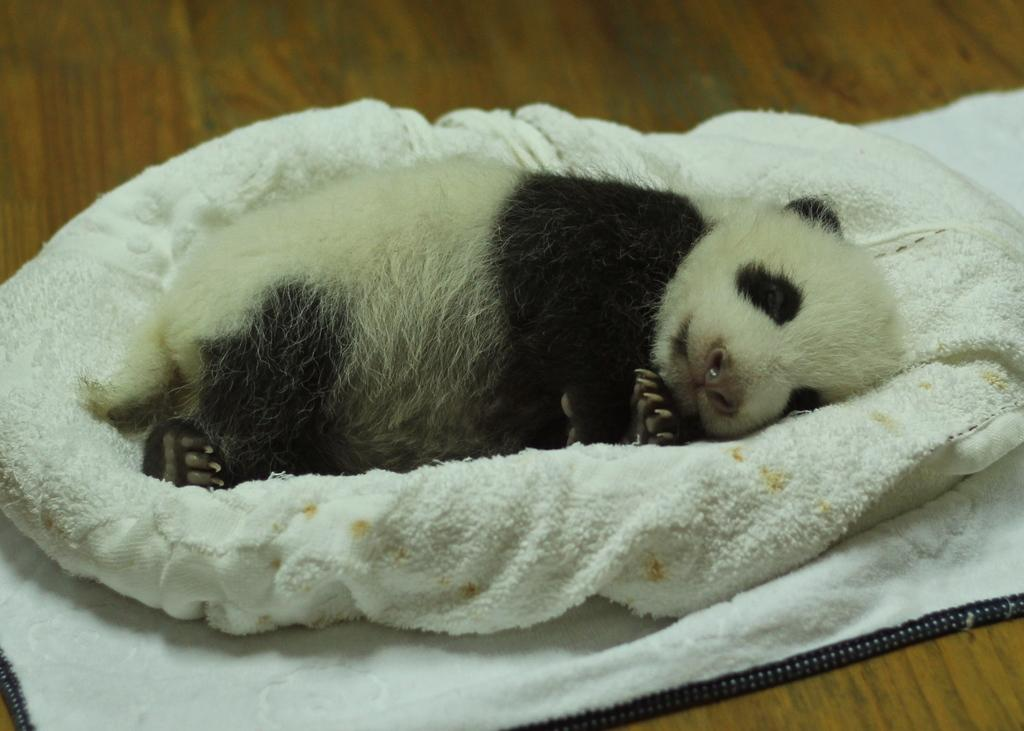What type of animal is in the picture? There is a small panda in the picture. What colors can be seen on the panda? The panda is white and black in color. What is the panda doing in the picture? The panda is sleeping. What is the panda placed on? The panda is placed on a white cloth. What is the white cloth placed on? The white cloth is on a wooden table top. What type of yarn is being used to create a camp around the panda in the image? There is no yarn or camp present in the image; it features a small panda sleeping on a white cloth on a wooden table top. 